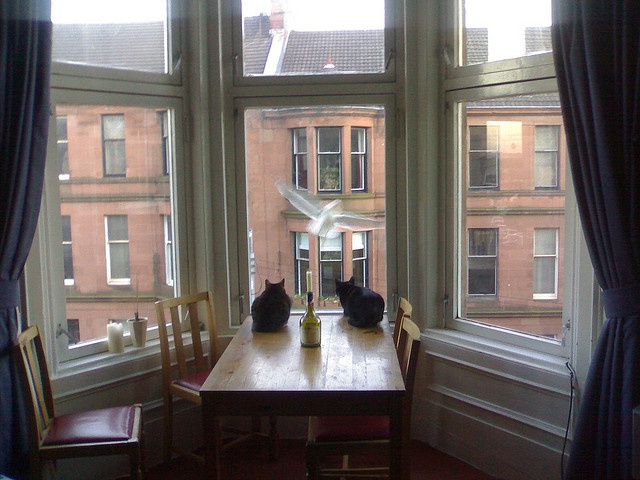Describe the objects in this image and their specific colors. I can see dining table in black, lightgray, darkgray, and gray tones, chair in black, gray, darkgray, and maroon tones, chair in black, maroon, and gray tones, chair in black, maroon, and gray tones, and cat in black, gray, and darkgray tones in this image. 